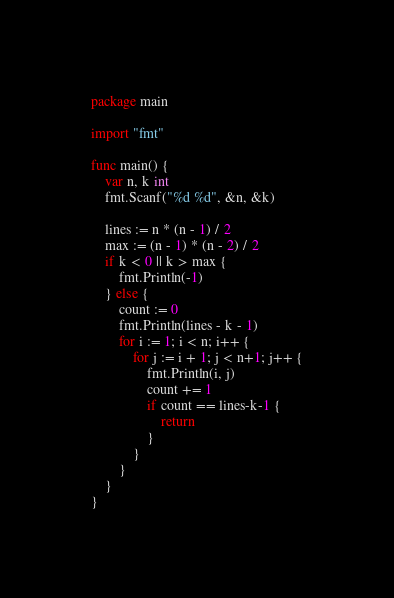<code> <loc_0><loc_0><loc_500><loc_500><_Go_>package main

import "fmt"

func main() {
	var n, k int
	fmt.Scanf("%d %d", &n, &k)

	lines := n * (n - 1) / 2
	max := (n - 1) * (n - 2) / 2
	if k < 0 || k > max {
		fmt.Println(-1)
	} else {
		count := 0
		fmt.Println(lines - k - 1)
		for i := 1; i < n; i++ {
			for j := i + 1; j < n+1; j++ {
				fmt.Println(i, j)
				count += 1
				if count == lines-k-1 {
					return
				}
			}
		}
	}
}
</code> 